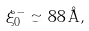<formula> <loc_0><loc_0><loc_500><loc_500>\xi _ { 0 } ^ { - } \simeq 8 8 \, { \AA } ,</formula> 